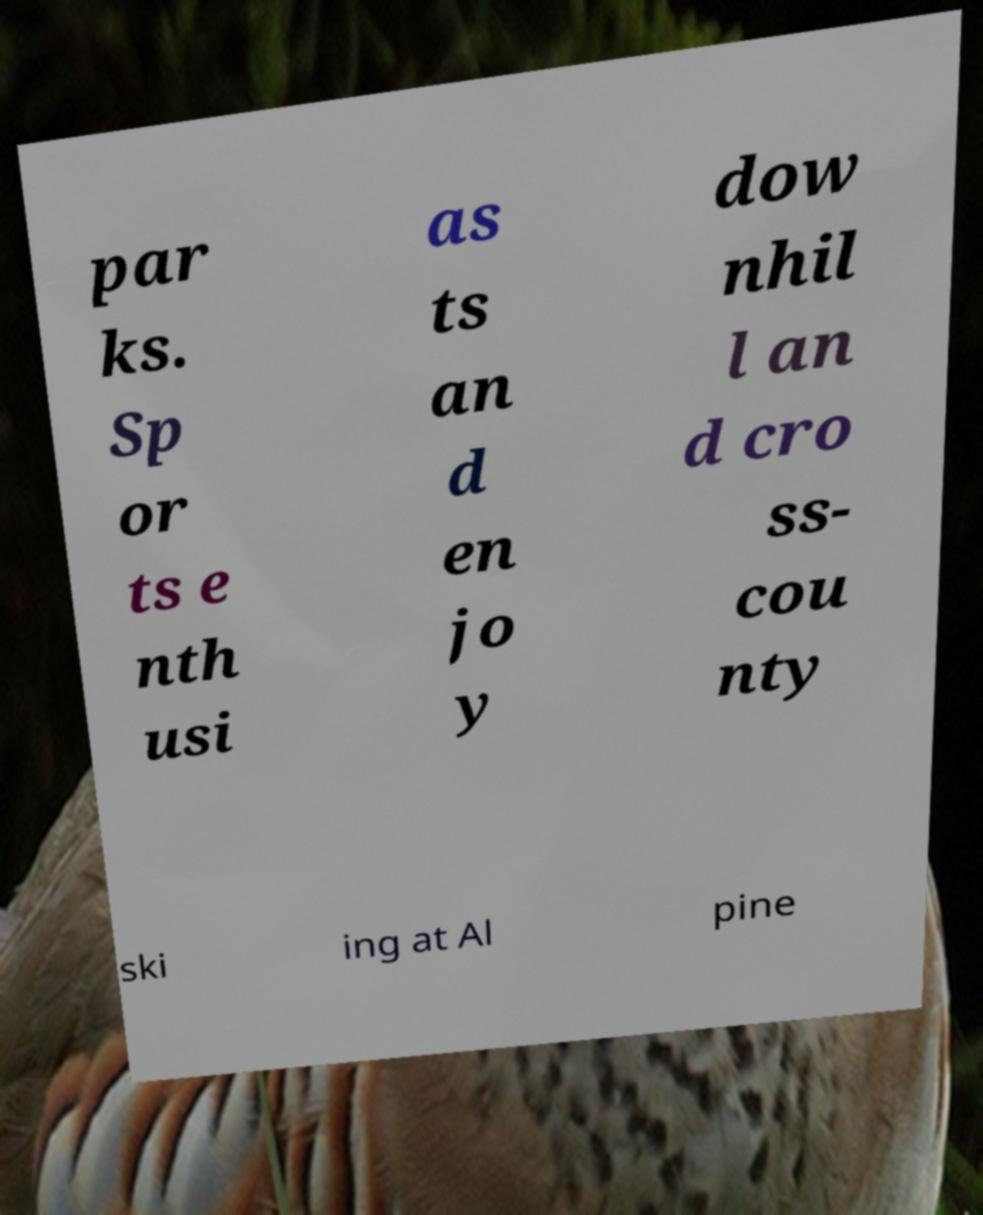Please read and relay the text visible in this image. What does it say? par ks. Sp or ts e nth usi as ts an d en jo y dow nhil l an d cro ss- cou nty ski ing at Al pine 